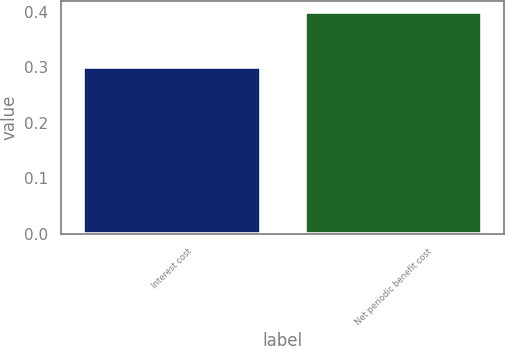<chart> <loc_0><loc_0><loc_500><loc_500><bar_chart><fcel>Interest cost<fcel>Net periodic benefit cost<nl><fcel>0.3<fcel>0.4<nl></chart> 